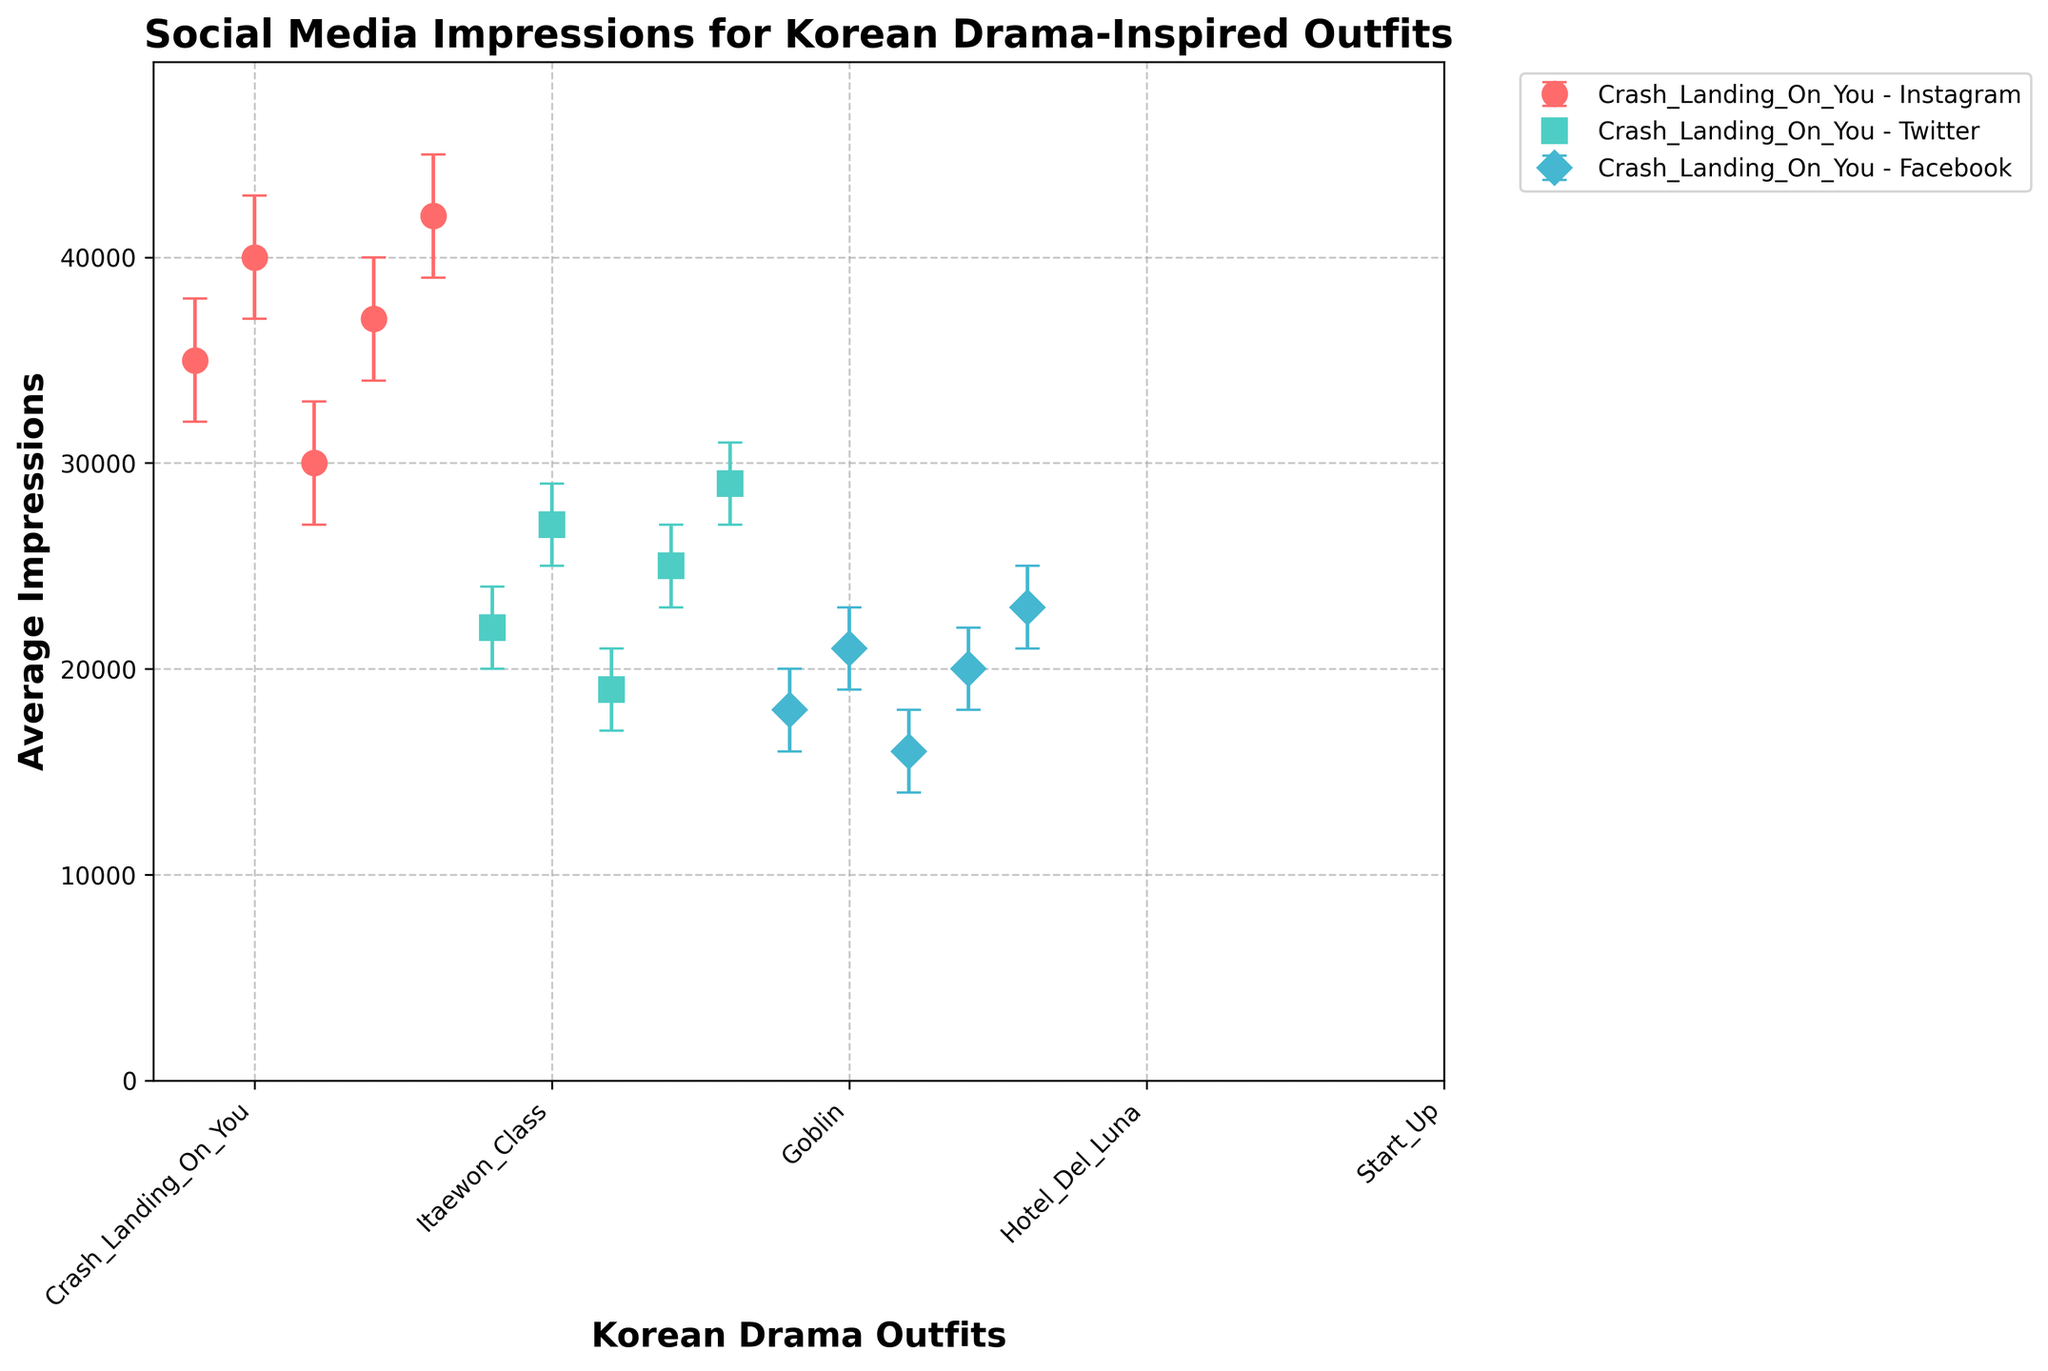What is the title of the figure? The title is usually displayed above the figure. It summarises the main point of the visualisation.
Answer: Social Media Impressions for Korean Drama-Inspired Outfits How many different Korean drama outfits are represented in the figure? The x-axis shows different Korean drama outfits with their corresponding labels beneath the axis. You can count the distinct labels to find the number of different outfits.
Answer: 5 Which social media platform has the highest average impressions for the "Start_Up" outfit? Look for the "Start_Up" outfit on the x-axis and then find the data points for each platform. Compare the heights to identify the platform with the highest value.
Answer: Instagram What is the range of daily interactions for the "Itaewon_Class" outfit on Twitter? The error bars show the range between the maximum and minimum impressions. Look for the Twitter data point for "Itaewon_Class" and observe the length of the error bars.
Answer: 25000 to 29000 Which outfit has the smallest average impressions on Facebook? Look for the Facebook data points and compare their heights to find the smallest one.
Answer: Goblin Between "Crash_Landing_On_You" and "Hotel_Del_Luna", which outfit performs better on Instagram in terms of average impressions? Compare the heights of the Instagram data points for both outfits to determine which one is higher.
Answer: Hotel_Del_Luna What is the difference in average impressions for "Goblin" between Instagram and Twitter? For "Goblin," note the average impressions on both Instagram and Twitter, then subtract the Twitter value from the Instagram value.
Answer: 11000 Which social media platform shows the most consistent daily interactions for the "Crash_Landing_On_You" outfit? Look at the error bars for each platform related to "Crash_Landing_On_You" and find the platform with the smallest error bars.
Answer: Facebook What is the overall trend in average impressions across all platforms for the "Start_Up" outfit? Observe all data points for the "Start_Up" outfit across different platforms and describe the general pattern in the heights of these points.
Answer: Instagram > Twitter > Facebook How do the average impressions on Instagram for "Itaewon_Class" compare to "Start_Up"? Compare the heights of the Instagram data points for "Itaewon_Class" and "Start_Up".
Answer: Start_Up's average impressions are higher 